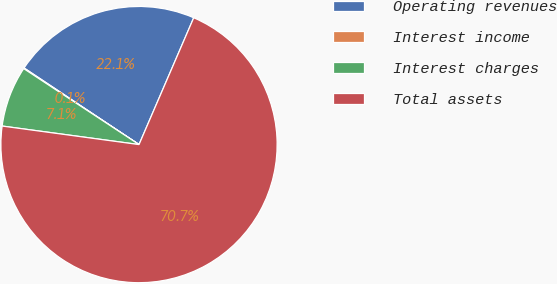Convert chart. <chart><loc_0><loc_0><loc_500><loc_500><pie_chart><fcel>Operating revenues<fcel>Interest income<fcel>Interest charges<fcel>Total assets<nl><fcel>22.13%<fcel>0.08%<fcel>7.13%<fcel>70.66%<nl></chart> 